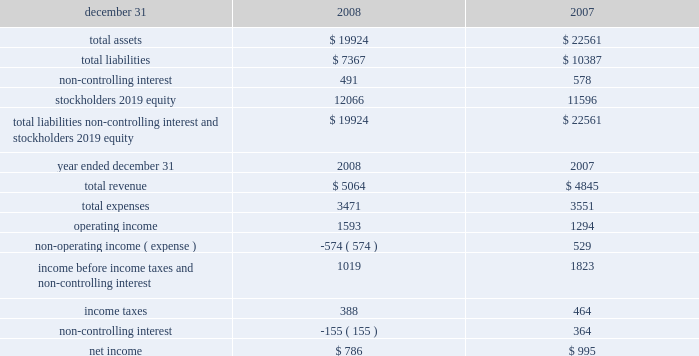Amount of unrecognized tax benefit related to permanent differences because a portion of those unrecognized benefits relate to state tax matters .
It is reasonably possible that the liability for uncertain tax positions could increase or decrease in the next twelve months due to completion of tax authorities 2019 exams or the expiration of statutes of limitations .
Management estimates that the liability for uncertain tax positions could decrease by $ 5 million within the next twelve months .
The consolidated federal income tax returns of the pnc financial services group , inc .
And subsidiaries through 2003 have been audited by the internal revenue service and we have resolved all disputed matters through the irs appeals division .
The internal revenue service is currently examining the 2004 through 2006 consolidated federal income tax returns of the pnc financial services group , inc .
And subsidiaries .
The consolidated federal income tax returns of national city corporation and subsidiaries through 2004 have been audited by the internal revenue service and we have reached agreement in principle on resolution of all disputed matters through the irs appeals division .
However , because the agreement is still subject to execution of a closing agreement we have not treated it as effectively settled .
The internal revenue service is currently examining the 2005 through 2007 consolidated federal income tax returns of national city corporation and subsidiaries , and we expect the 2008 federal income tax return to begin being audited as soon as it is filed .
New york , new jersey , maryland and new york city are principally where we were subject to state and local income tax prior to our acquisition of national city .
The state of new york is currently in the process of closing the 2002 to 2004 audit and will begin auditing the years 2005 and 2006 .
New york city is currently auditing 2004 and 2005 .
However , years 2002 and 2003 remain subject to examination by new york city pending completion of the new york state audit .
Through 2006 , blackrock is included in our new york and new york city combined tax filings and constituted most of the tax liability .
Years subsequent to 2004 remain subject to examination by new jersey and years subsequent to 2005 remain subject to examination by maryland .
National city was principally subject to state and local income tax in california , florida , illinois , indiana , and missouri .
Audits currently in process for these states include : california ( 2003-2004 ) , illinois ( 2004-2006 ) and missouri ( 2003-2005 ) .
We will now also be principally subject to tax in those states .
In the ordinary course of business we are routinely subject to audit by the taxing authorities of these states and at any given time a number of audits will be in process .
Our policy is to classify interest and penalties associated with income taxes as income taxes .
At january 1 , 2008 , we had accrued $ 91 million of interest related to tax positions , most of which related to our cross-border leasing transactions .
The total accrued interest and penalties at december 31 , 2008 was $ 164 million .
While the leasing related interest decreased with a payment to the irs , the $ 73 million net increase primarily resulted from our acquisition of national city .
Note 22 summarized financial information of blackrock as required by sec regulation s-x , summarized consolidated financial information of blackrock follows ( in millions ) . .
Note 23 regulatory matters we are subject to the regulations of certain federal and state agencies and undergo periodic examinations by such regulatory authorities .
The access to and cost of funding new business initiatives including acquisitions , the ability to pay dividends , the level of deposit insurance costs , and the level and nature of regulatory oversight depend , in large part , on a financial institution 2019s capital strength .
The minimum us regulatory capital ratios are 4% ( 4 % ) for tier 1 risk-based , 8% ( 8 % ) for total risk- based and 4% ( 4 % ) for leverage .
However , regulators may require higher capital levels when particular circumstances warrant .
To qualify as 201cwell capitalized , 201d regulators require banks to maintain capital ratios of at least 6% ( 6 % ) for tier 1 risk-based , 10% ( 10 % ) for total risk-based and 5% ( 5 % ) for leverage .
At december 31 , 2008 and december 31 , 2007 , each of our domestic bank subsidiaries met the 201cwell capitalized 201d capital ratio requirements. .
In 2008 what was the debt to equity ratio? 
Computations: (7367 / (19924 - 7367))
Answer: 0.58668. 